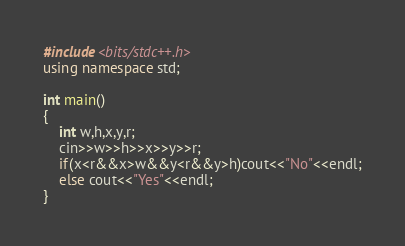Convert code to text. <code><loc_0><loc_0><loc_500><loc_500><_C++_>#include<bits/stdc++.h>
using namespace std;

int main()
{
    int w,h,x,y,r;
    cin>>w>>h>>x>>y>>r;
    if(x<r&&x>w&&y<r&&y>h)cout<<"No"<<endl;
    else cout<<"Yes"<<endl;
}
</code> 